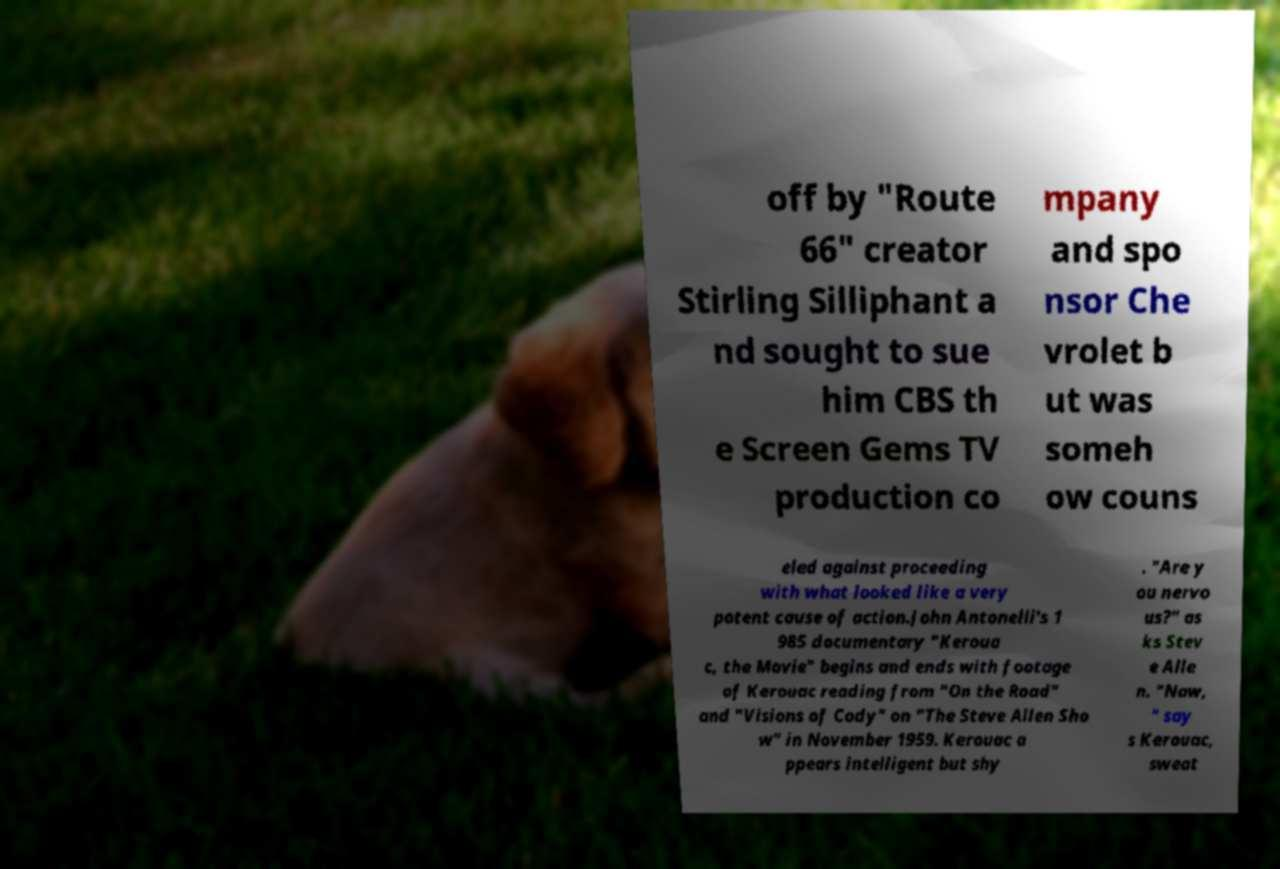I need the written content from this picture converted into text. Can you do that? off by "Route 66" creator Stirling Silliphant a nd sought to sue him CBS th e Screen Gems TV production co mpany and spo nsor Che vrolet b ut was someh ow couns eled against proceeding with what looked like a very potent cause of action.John Antonelli's 1 985 documentary "Keroua c, the Movie" begins and ends with footage of Kerouac reading from "On the Road" and "Visions of Cody" on "The Steve Allen Sho w" in November 1959. Kerouac a ppears intelligent but shy . "Are y ou nervo us?" as ks Stev e Alle n. "Naw, " say s Kerouac, sweat 